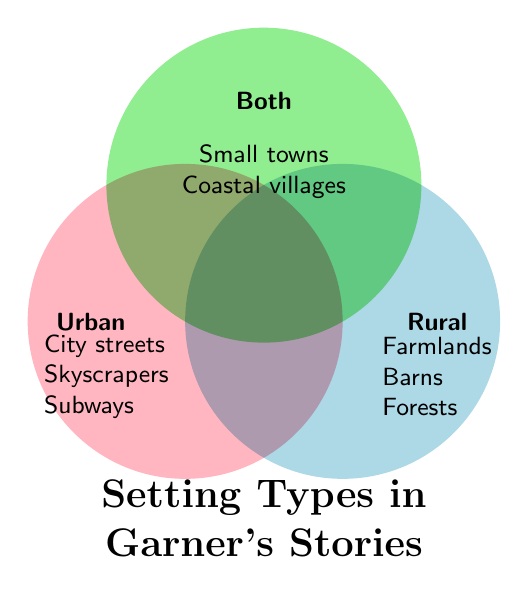What is the title of the Venn Diagram? The title is located at the bottom center of the Venn Diagram. It states "Setting Types in Garner's Stories."
Answer: Setting Types in Garner's Stories Which setting is unique to the Urban category? In the Urban category, the setting that is not shared with any other categories includes City streets, Skyscrapers, Subways, Nightclubs, and Apartments.
Answer: Apartments How many unique settings are listed under Rural? The Rural category includes five unique settings: Farmlands, Barns, Forests, Cornfields, and Ranches.
Answer: Five Which setting is shared by both Urban and Rural but not by the Both category? The diagram does not show any settings shared between Urban and Rural directly; only 'Both' category shows shared settings across them.
Answer: None Which category has the setting 'University campuses'? The setting 'University campuses' belongs to the Both category.
Answer: Both Which category includes Cornfields? The Rural category includes Cornfields.
Answer: Rural How many settings are listed in the "Both" category? The diagram shows three settings in the "Both" category: Small towns, Coastal villages, and Mountain resorts.
Answer: Three Is 'Subways' listed under Urban, Rural, or Both? 'Subways' is listed under the Urban category.
Answer: Urban Which category includes the setting 'Coastal villages'? Listed as part of the 'Both' category, 'Coastal villages' is shared between Urban and Rural settings.
Answer: Both What setting types are at the intersection of Urban, Rural, and Both categories? No specific setting type is listed directly at the intersection of all three categories in the given diagram.
Answer: None 